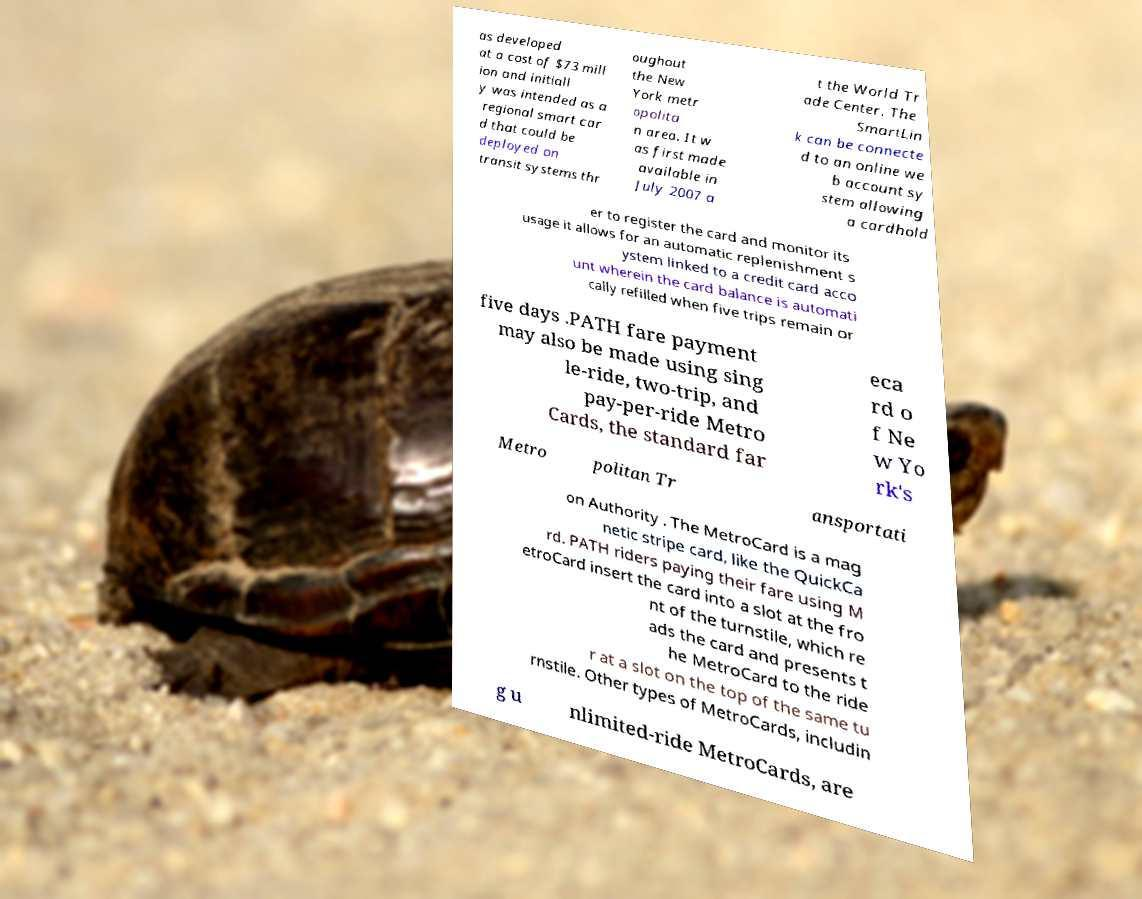Please identify and transcribe the text found in this image. as developed at a cost of $73 mill ion and initiall y was intended as a regional smart car d that could be deployed on transit systems thr oughout the New York metr opolita n area. It w as first made available in July 2007 a t the World Tr ade Center. The SmartLin k can be connecte d to an online we b account sy stem allowing a cardhold er to register the card and monitor its usage it allows for an automatic replenishment s ystem linked to a credit card acco unt wherein the card balance is automati cally refilled when five trips remain or five days .PATH fare payment may also be made using sing le-ride, two-trip, and pay-per-ride Metro Cards, the standard far eca rd o f Ne w Yo rk's Metro politan Tr ansportati on Authority . The MetroCard is a mag netic stripe card, like the QuickCa rd. PATH riders paying their fare using M etroCard insert the card into a slot at the fro nt of the turnstile, which re ads the card and presents t he MetroCard to the ride r at a slot on the top of the same tu rnstile. Other types of MetroCards, includin g u nlimited-ride MetroCards, are 